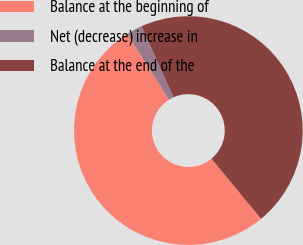<chart> <loc_0><loc_0><loc_500><loc_500><pie_chart><fcel>Balance at the beginning of<fcel>Net (decrease) increase in<fcel>Balance at the end of the<nl><fcel>52.0%<fcel>2.26%<fcel>45.74%<nl></chart> 